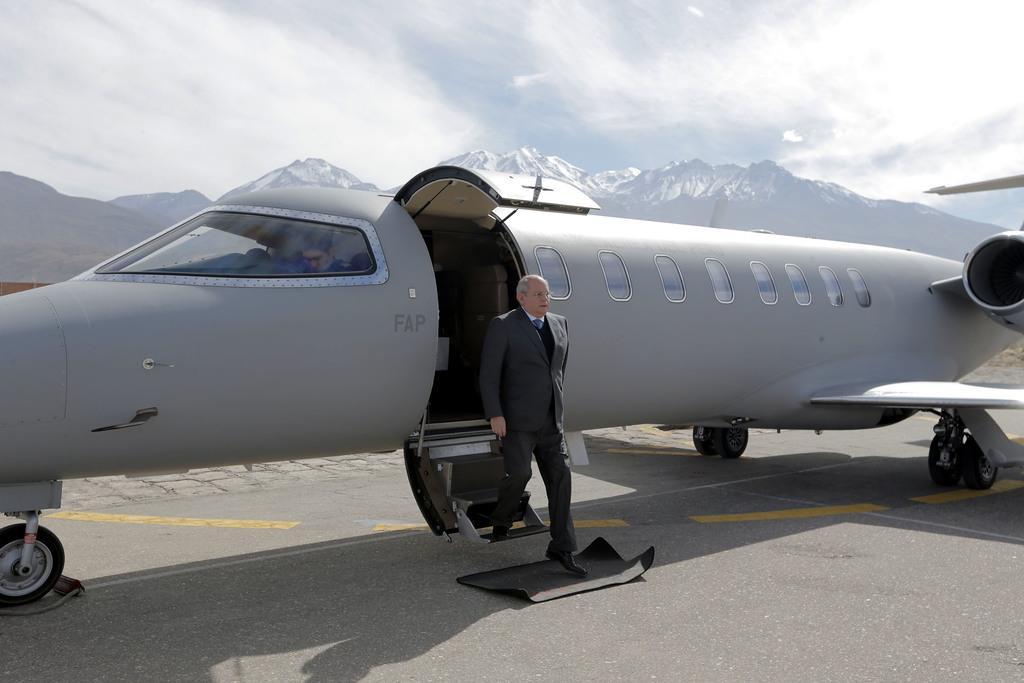Please provide a concise description of this image. In this image there is a person exiting from the plane. In the cockpit there is a pilot. In the background of the image there are mountains and sky. 